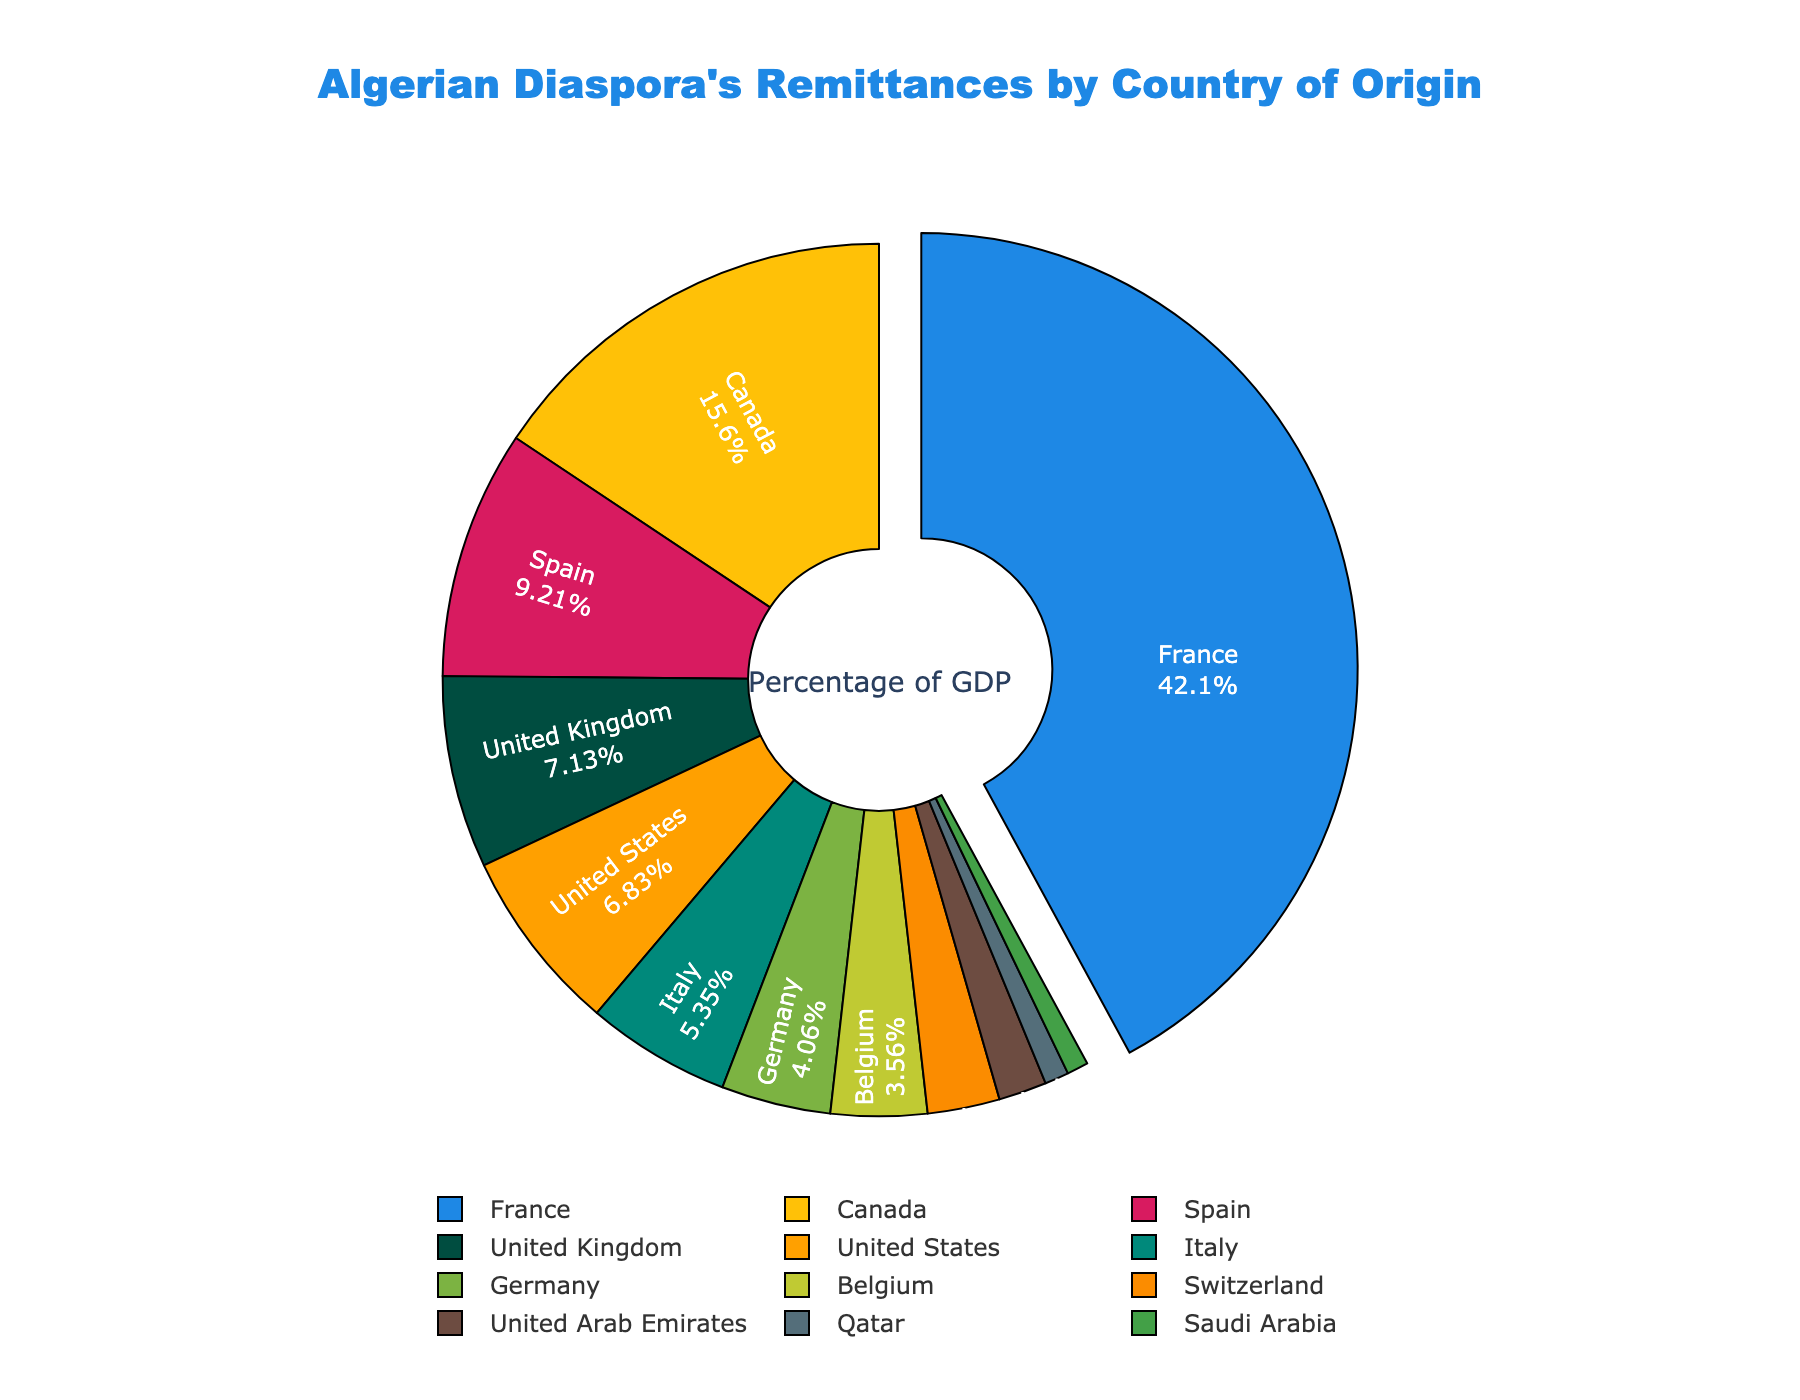Which country contributes the highest share of Algerian diaspora's remittances? The chart displays the contributions of various countries. The largest segment, pulled out for emphasis, represents France.
Answer: France Which two countries together contribute more than 50% of the remittances? Sum the percentages of the largest contributing countries until the total is above 50%. France with 42.5% and Canada with 15.8% together contribute 58.3%.
Answer: France and Canada How much more do remittances from France contribute compared to the United States? Find the percentages for both countries and subtract the smaller from the larger. France contributes 42.5% and the United States 6.9%, so the difference is 42.5% - 6.9% = 35.6%.
Answer: 35.6% Which countries contribute less than 5% each to Algerian remittances? Identify the countries with percentages below 5%. These are Germany (4.1%), Belgium (3.6%), Switzerland (2.7%), United Arab Emirates (1.8%), Qatar (0.9%), and Saudi Arabia (0.8%).
Answer: Germany, Belgium, Switzerland, United Arab Emirates, Qatar, Saudi Arabia What is the combined contribution from Spain and the United Kingdom? Add the percentages for Spain and the United Kingdom. Spain contributes 9.3% and the United Kingdom 7.2%, so their combined contribution is 9.3% + 7.2% = 16.5%.
Answer: 16.5% What color represents the country contributing 15.8% of the remittances? Look at the segment marked with 15.8%. The corresponding color is yellow.
Answer: Yellow Rank the top three countries by their contribution to the remittances. List the countries in order of their percentage contributions. The top three are France (42.5%), Canada (15.8%), and Spain (9.3%).
Answer: France, Canada, Spain How does the combined contribution of Belgium and Switzerland compare to that of the United States? Add the percentages of Belgium and Switzerland and compare them to the United States. Belgium + Switzerland = 3.6% + 2.7% = 6.3%, which is less than the United States at 6.9%.
Answer: Less Which region has the least representation in Algeria's remittances? Look for the origin countries with the lowest contributions. The Middle East is represented by the United Arab Emirates (1.8%), Qatar (0.9%), and Saudi Arabia (0.8%), collectively contributing 3.5%, the least amount as a region.
Answer: Middle East 